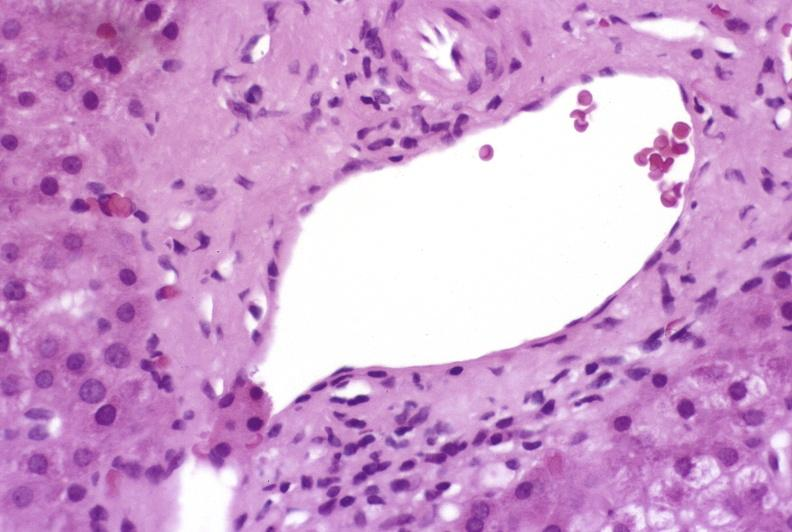s hepatobiliary present?
Answer the question using a single word or phrase. Yes 